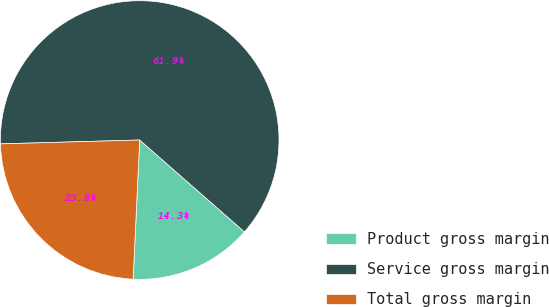Convert chart. <chart><loc_0><loc_0><loc_500><loc_500><pie_chart><fcel>Product gross margin<fcel>Service gross margin<fcel>Total gross margin<nl><fcel>14.29%<fcel>61.9%<fcel>23.81%<nl></chart> 